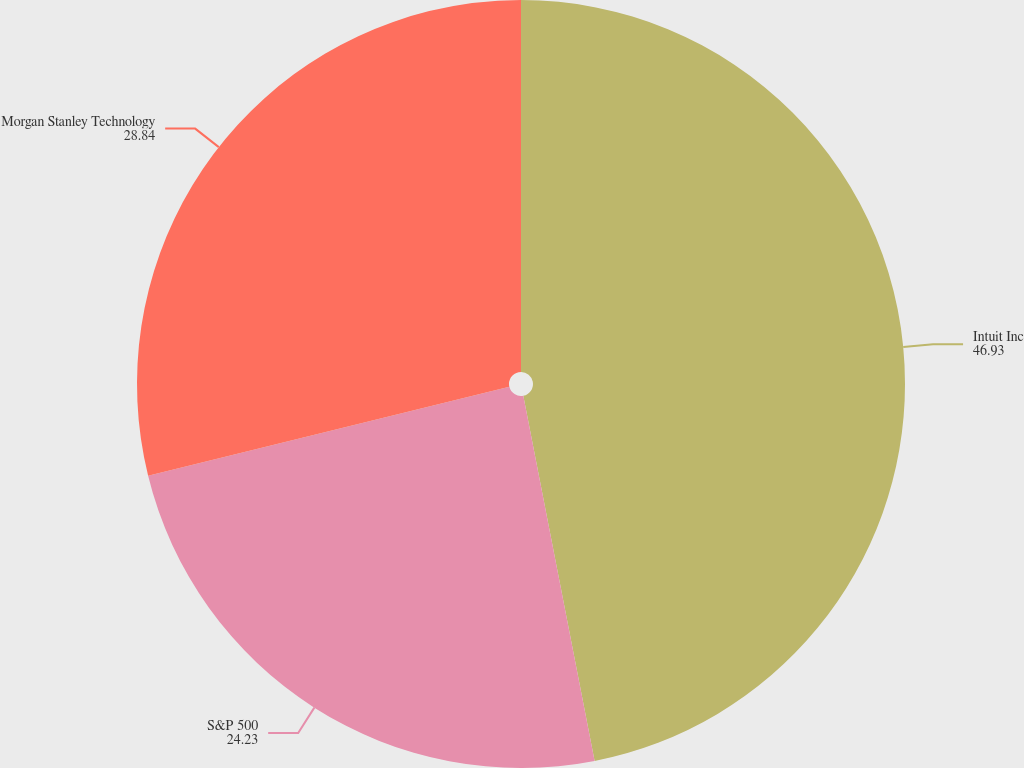Convert chart to OTSL. <chart><loc_0><loc_0><loc_500><loc_500><pie_chart><fcel>Intuit Inc<fcel>S&P 500<fcel>Morgan Stanley Technology<nl><fcel>46.93%<fcel>24.23%<fcel>28.84%<nl></chart> 